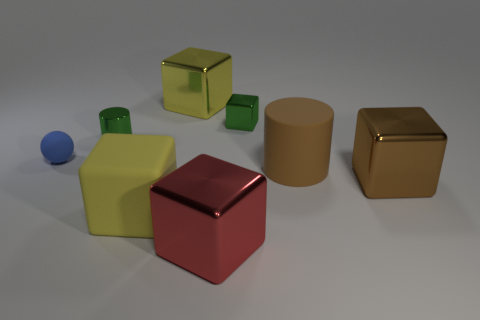Add 2 blocks. How many objects exist? 10 Subtract all large cubes. How many cubes are left? 1 Subtract all brown cylinders. How many cylinders are left? 1 Subtract 0 cyan spheres. How many objects are left? 8 Subtract all spheres. How many objects are left? 7 Subtract 1 cylinders. How many cylinders are left? 1 Subtract all green cubes. Subtract all cyan cylinders. How many cubes are left? 4 Subtract all cyan balls. How many brown blocks are left? 1 Subtract all big cylinders. Subtract all large brown cubes. How many objects are left? 6 Add 2 metallic cubes. How many metallic cubes are left? 6 